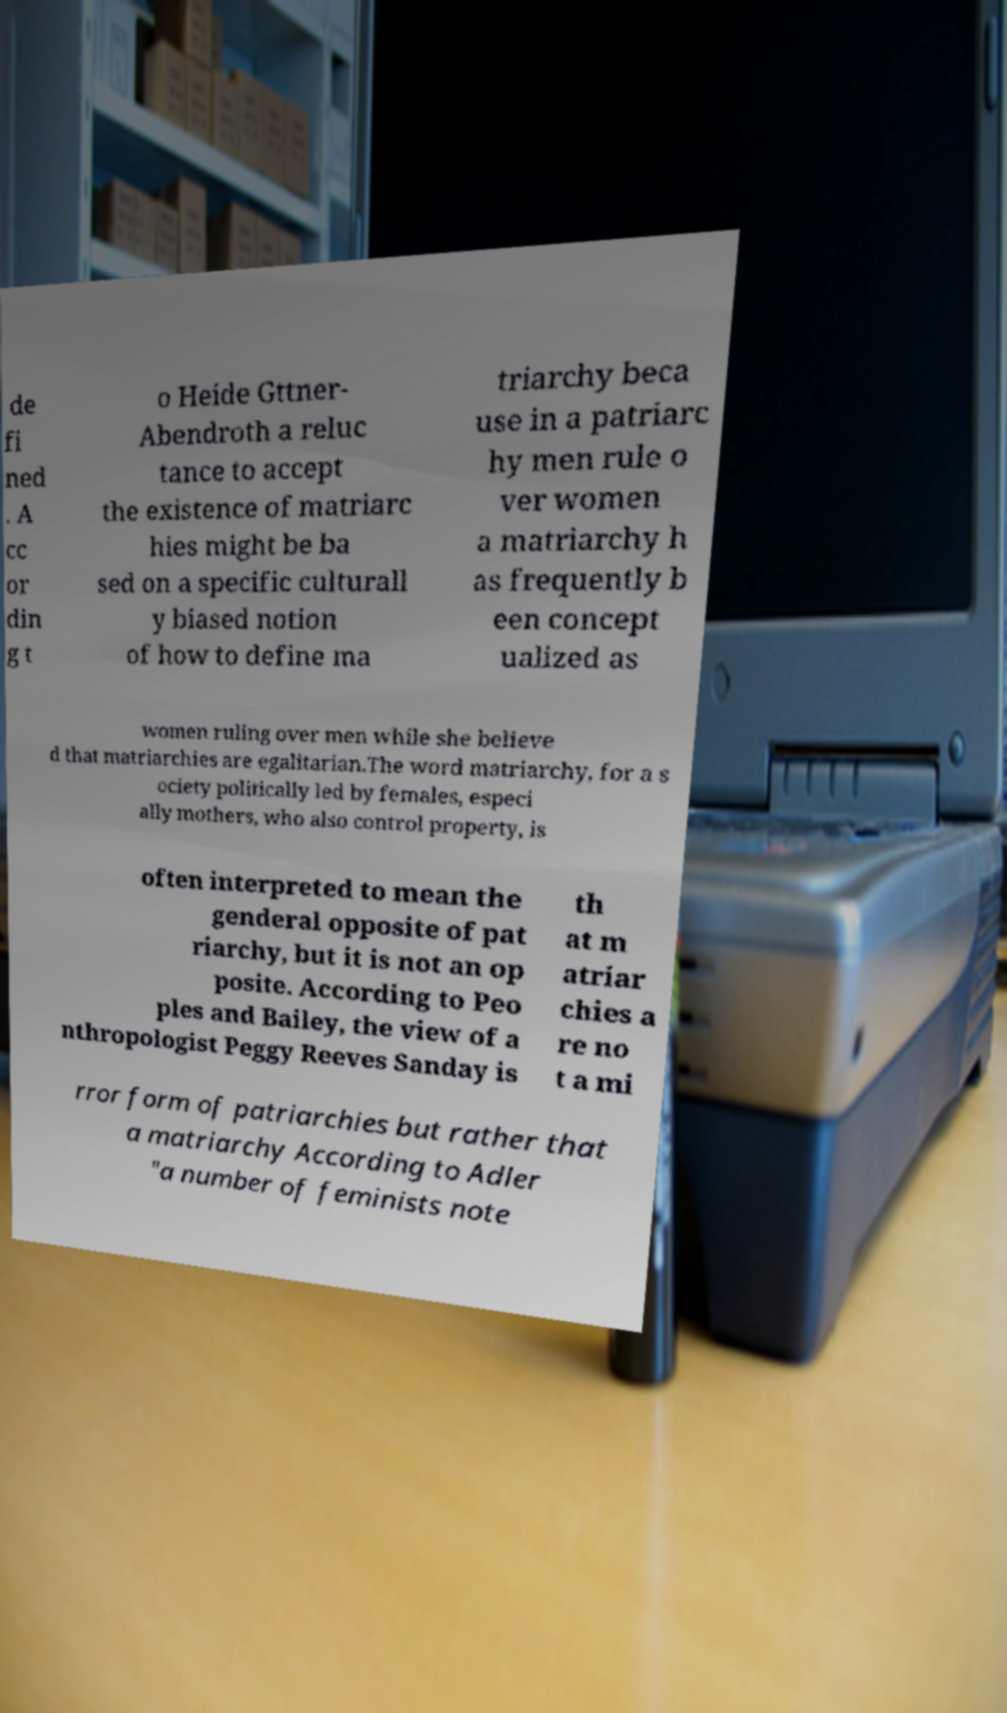Please identify and transcribe the text found in this image. de fi ned . A cc or din g t o Heide Gttner- Abendroth a reluc tance to accept the existence of matriarc hies might be ba sed on a specific culturall y biased notion of how to define ma triarchy beca use in a patriarc hy men rule o ver women a matriarchy h as frequently b een concept ualized as women ruling over men while she believe d that matriarchies are egalitarian.The word matriarchy, for a s ociety politically led by females, especi ally mothers, who also control property, is often interpreted to mean the genderal opposite of pat riarchy, but it is not an op posite. According to Peo ples and Bailey, the view of a nthropologist Peggy Reeves Sanday is th at m atriar chies a re no t a mi rror form of patriarchies but rather that a matriarchy According to Adler "a number of feminists note 